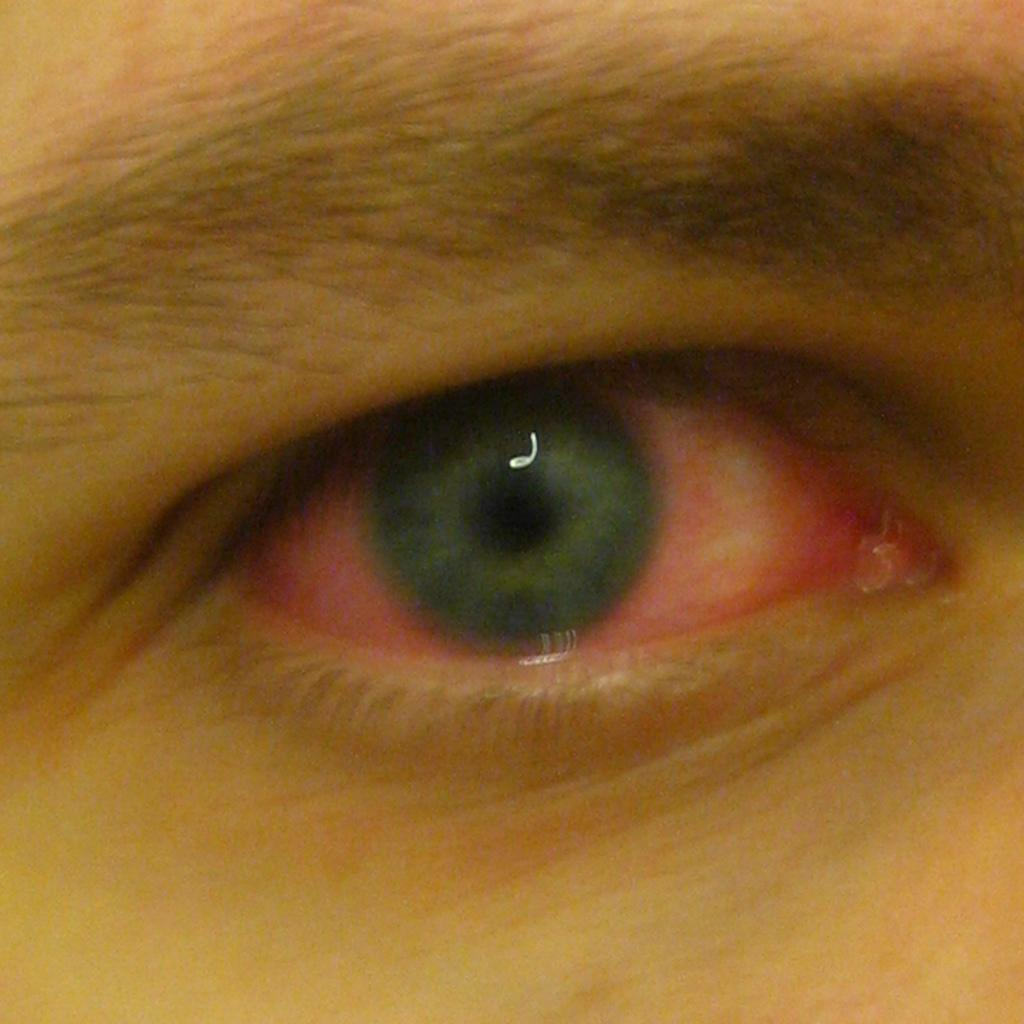What is the main subject of the image? The main subject of the image is an eye. What color is the eye in the image? The eye is in red color. What type of teaching is being conducted in the image? There is no teaching or any indication of a learning environment in the image; it only features a red eye. What kind of cap is the person wearing in the image? There is no person or cap present in the image; it only features a red eye. 